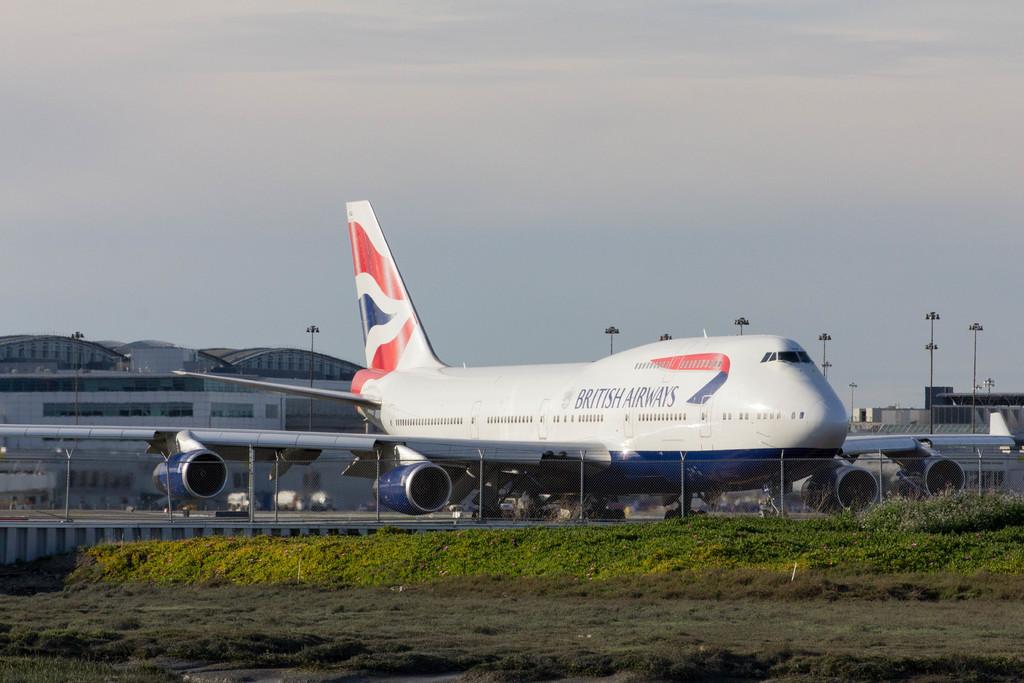What county of airways?
Give a very brief answer. British. What is the name of hte plane?
Your answer should be compact. British airways. 